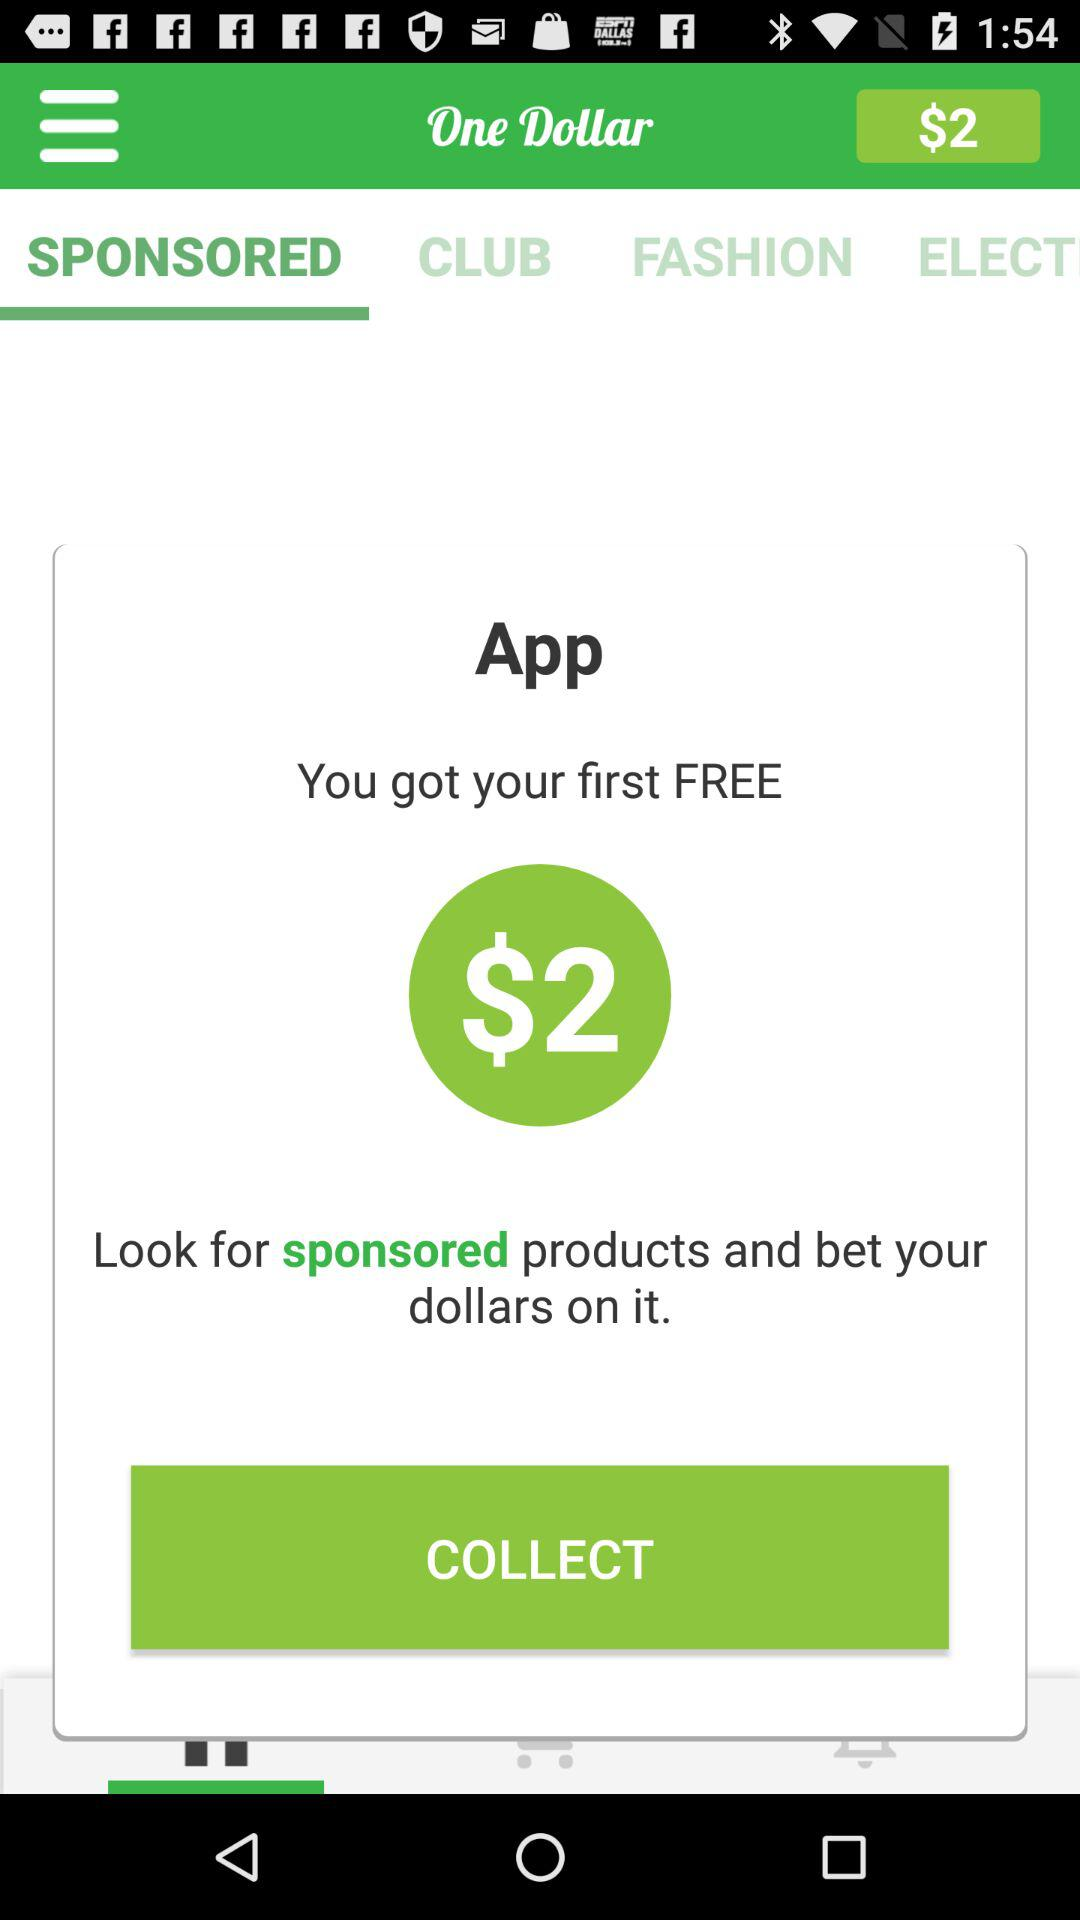What is the free amount that I have received? The free amount that you have received is $2. 